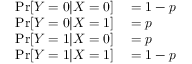Convert formula to latex. <formula><loc_0><loc_0><loc_500><loc_500>\begin{array} { r l } { \Pr [ Y = 0 | X = 0 ] } & = 1 - p } \\ { \Pr [ Y = 0 | X = 1 ] } & = p } \\ { \Pr [ Y = 1 | X = 0 ] } & = p } \\ { \Pr [ Y = 1 | X = 1 ] } & = 1 - p } \end{array}</formula> 